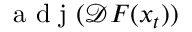<formula> <loc_0><loc_0><loc_500><loc_500>a d j ( \mathcal { D } F ( x _ { t } ) )</formula> 